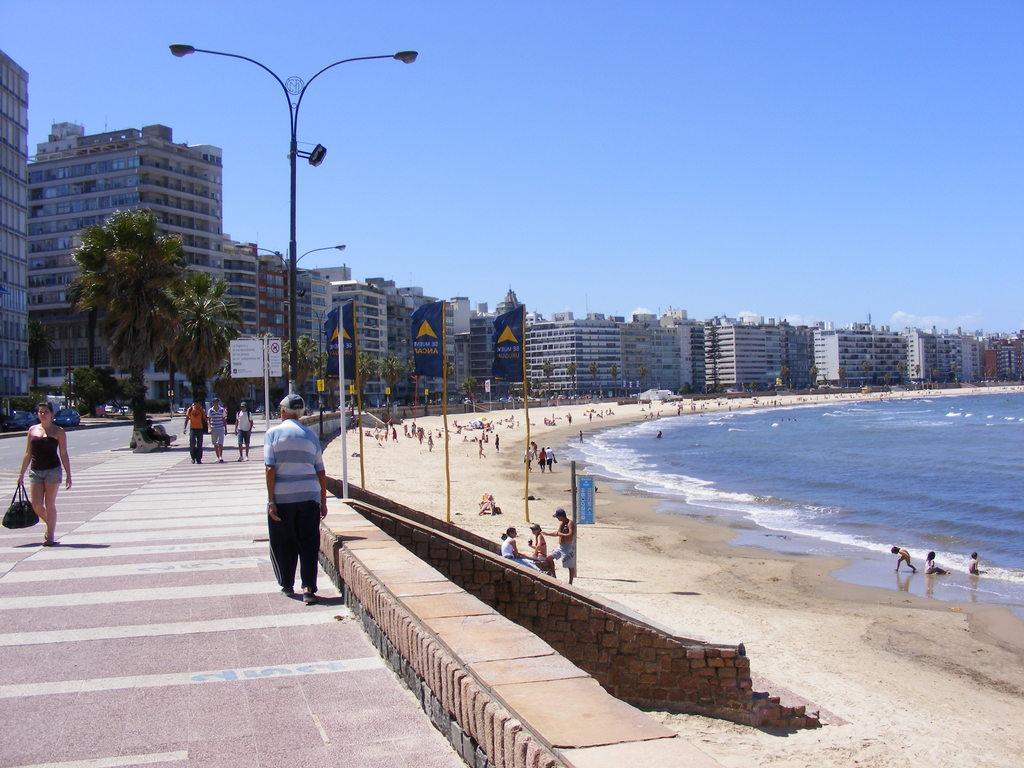Could you give a brief overview of what you see in this image? Here there are few persons walking on the footpath and a woman is a holding a bag in her hands. In the background there are buildings,windows,poles,street lights,trees and on the sand there are few people standing and walking. We can also see hoardings,water on the right side and on the left side there are vehicles on the ground and there are clouds in the sky. 